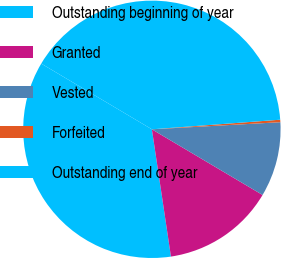Convert chart to OTSL. <chart><loc_0><loc_0><loc_500><loc_500><pie_chart><fcel>Outstanding beginning of year<fcel>Granted<fcel>Vested<fcel>Forfeited<fcel>Outstanding end of year<nl><fcel>35.89%<fcel>14.11%<fcel>9.4%<fcel>0.31%<fcel>40.28%<nl></chart> 